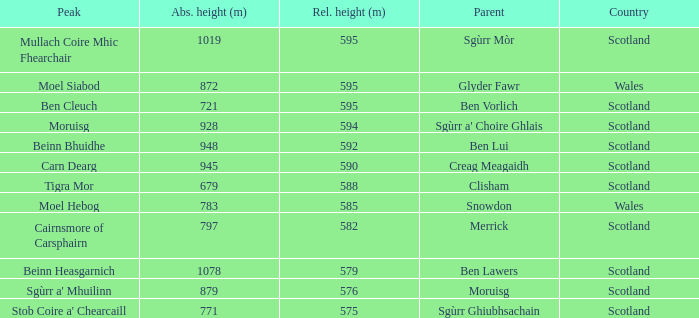What is the relative height of Scotland with Ben Vorlich as parent? 1.0. 